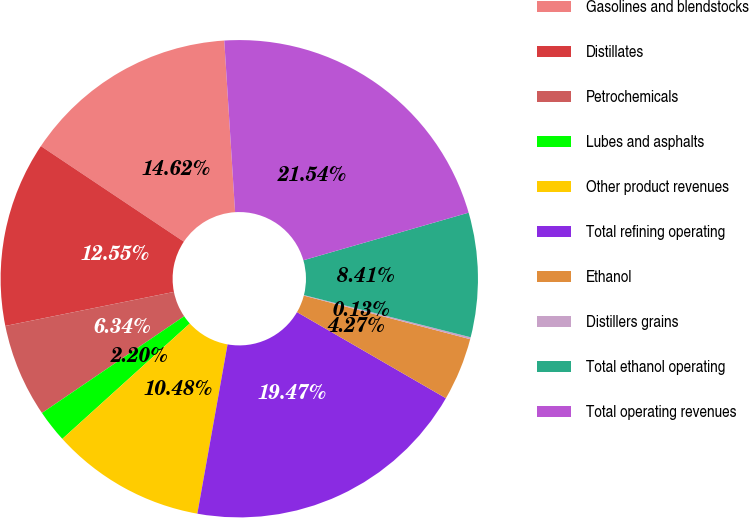Convert chart. <chart><loc_0><loc_0><loc_500><loc_500><pie_chart><fcel>Gasolines and blendstocks<fcel>Distillates<fcel>Petrochemicals<fcel>Lubes and asphalts<fcel>Other product revenues<fcel>Total refining operating<fcel>Ethanol<fcel>Distillers grains<fcel>Total ethanol operating<fcel>Total operating revenues<nl><fcel>14.62%<fcel>12.55%<fcel>6.34%<fcel>2.2%<fcel>10.48%<fcel>19.47%<fcel>4.27%<fcel>0.13%<fcel>8.41%<fcel>21.54%<nl></chart> 